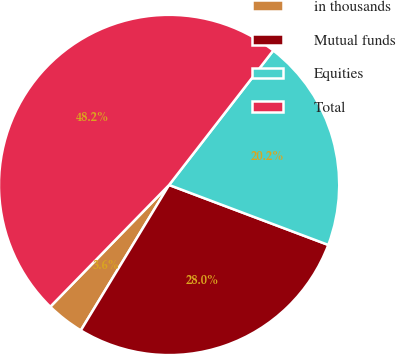Convert chart to OTSL. <chart><loc_0><loc_0><loc_500><loc_500><pie_chart><fcel>in thousands<fcel>Mutual funds<fcel>Equities<fcel>Total<nl><fcel>3.62%<fcel>27.95%<fcel>20.24%<fcel>48.19%<nl></chart> 